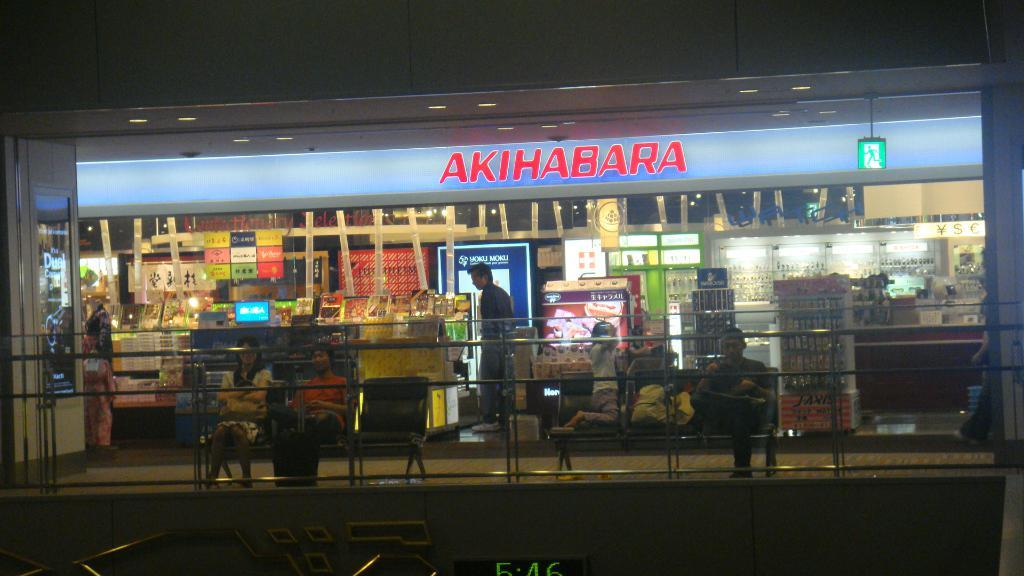<image>
Give a short and clear explanation of the subsequent image. The Akihabara store is brightly lit up at night 